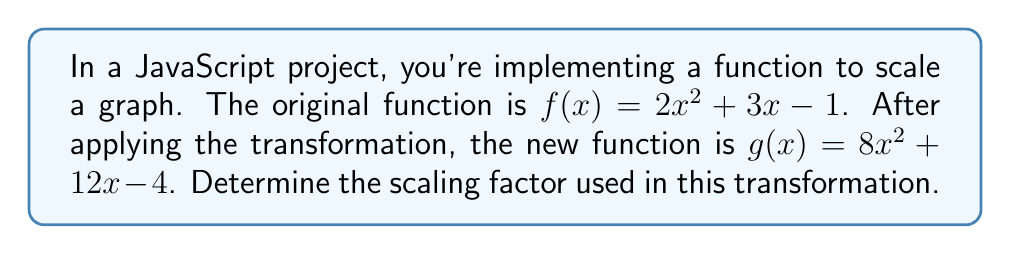Teach me how to tackle this problem. To find the scaling factor, we need to compare the coefficients of the original function $f(x)$ with those of the transformed function $g(x)$. 

Let's break it down step by step:

1. Original function: $f(x) = 2x^2 + 3x - 1$
2. Transformed function: $g(x) = 8x^2 + 12x - 4$

3. Compare the coefficients:
   - $x^2$ term: $2 \rightarrow 8$
   - $x$ term: $3 \rightarrow 12$
   - Constant term: $-1 \rightarrow -4$

4. Calculate the ratio for each term:
   - For $x^2$: $\frac{8}{2} = 4$
   - For $x$: $\frac{12}{3} = 4$
   - For constant: $\frac{-4}{-1} = 4$

5. We can see that all terms have been multiplied by 4.

In function transformations, when we multiply the entire function by a factor $a$, it results in a vertical stretch (if $|a| > 1$) or compression (if $0 < |a| < 1$) of the graph.

The general form of this transformation is:
$g(x) = af(x)$

In this case, $a = 4$, so the transformation can be written as:
$g(x) = 4f(x)$

This scaling factor of 4 means that every y-coordinate of the original function has been multiplied by 4, resulting in a vertical stretch of the graph.
Answer: The scaling factor is 4. 